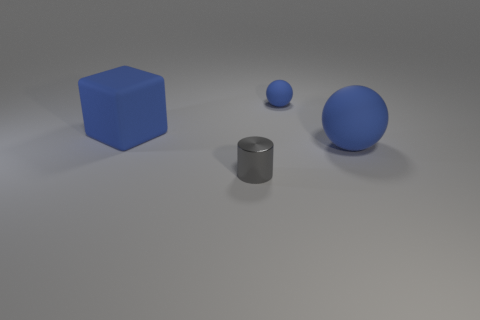What shape is the tiny rubber thing that is the same color as the large matte sphere?
Your answer should be very brief. Sphere. There is a thing that is both in front of the blue matte cube and behind the gray metallic cylinder; what material is it?
Give a very brief answer. Rubber. Are there any other things that have the same shape as the tiny gray shiny thing?
Your answer should be compact. No. How many objects are both in front of the blue matte cube and behind the tiny metallic object?
Your response must be concise. 1. What is the small blue thing made of?
Your response must be concise. Rubber. Are there an equal number of small gray cylinders on the left side of the gray cylinder and small brown rubber balls?
Your response must be concise. Yes. What number of tiny metallic things have the same shape as the small blue matte thing?
Your response must be concise. 0. How many objects are either blue matte objects that are left of the small matte sphere or big rubber objects?
Your response must be concise. 2. There is a blue thing behind the big blue rubber object that is to the left of the matte sphere that is in front of the tiny sphere; what is its shape?
Offer a terse response. Sphere. What shape is the tiny blue object that is made of the same material as the large blue block?
Keep it short and to the point. Sphere. 